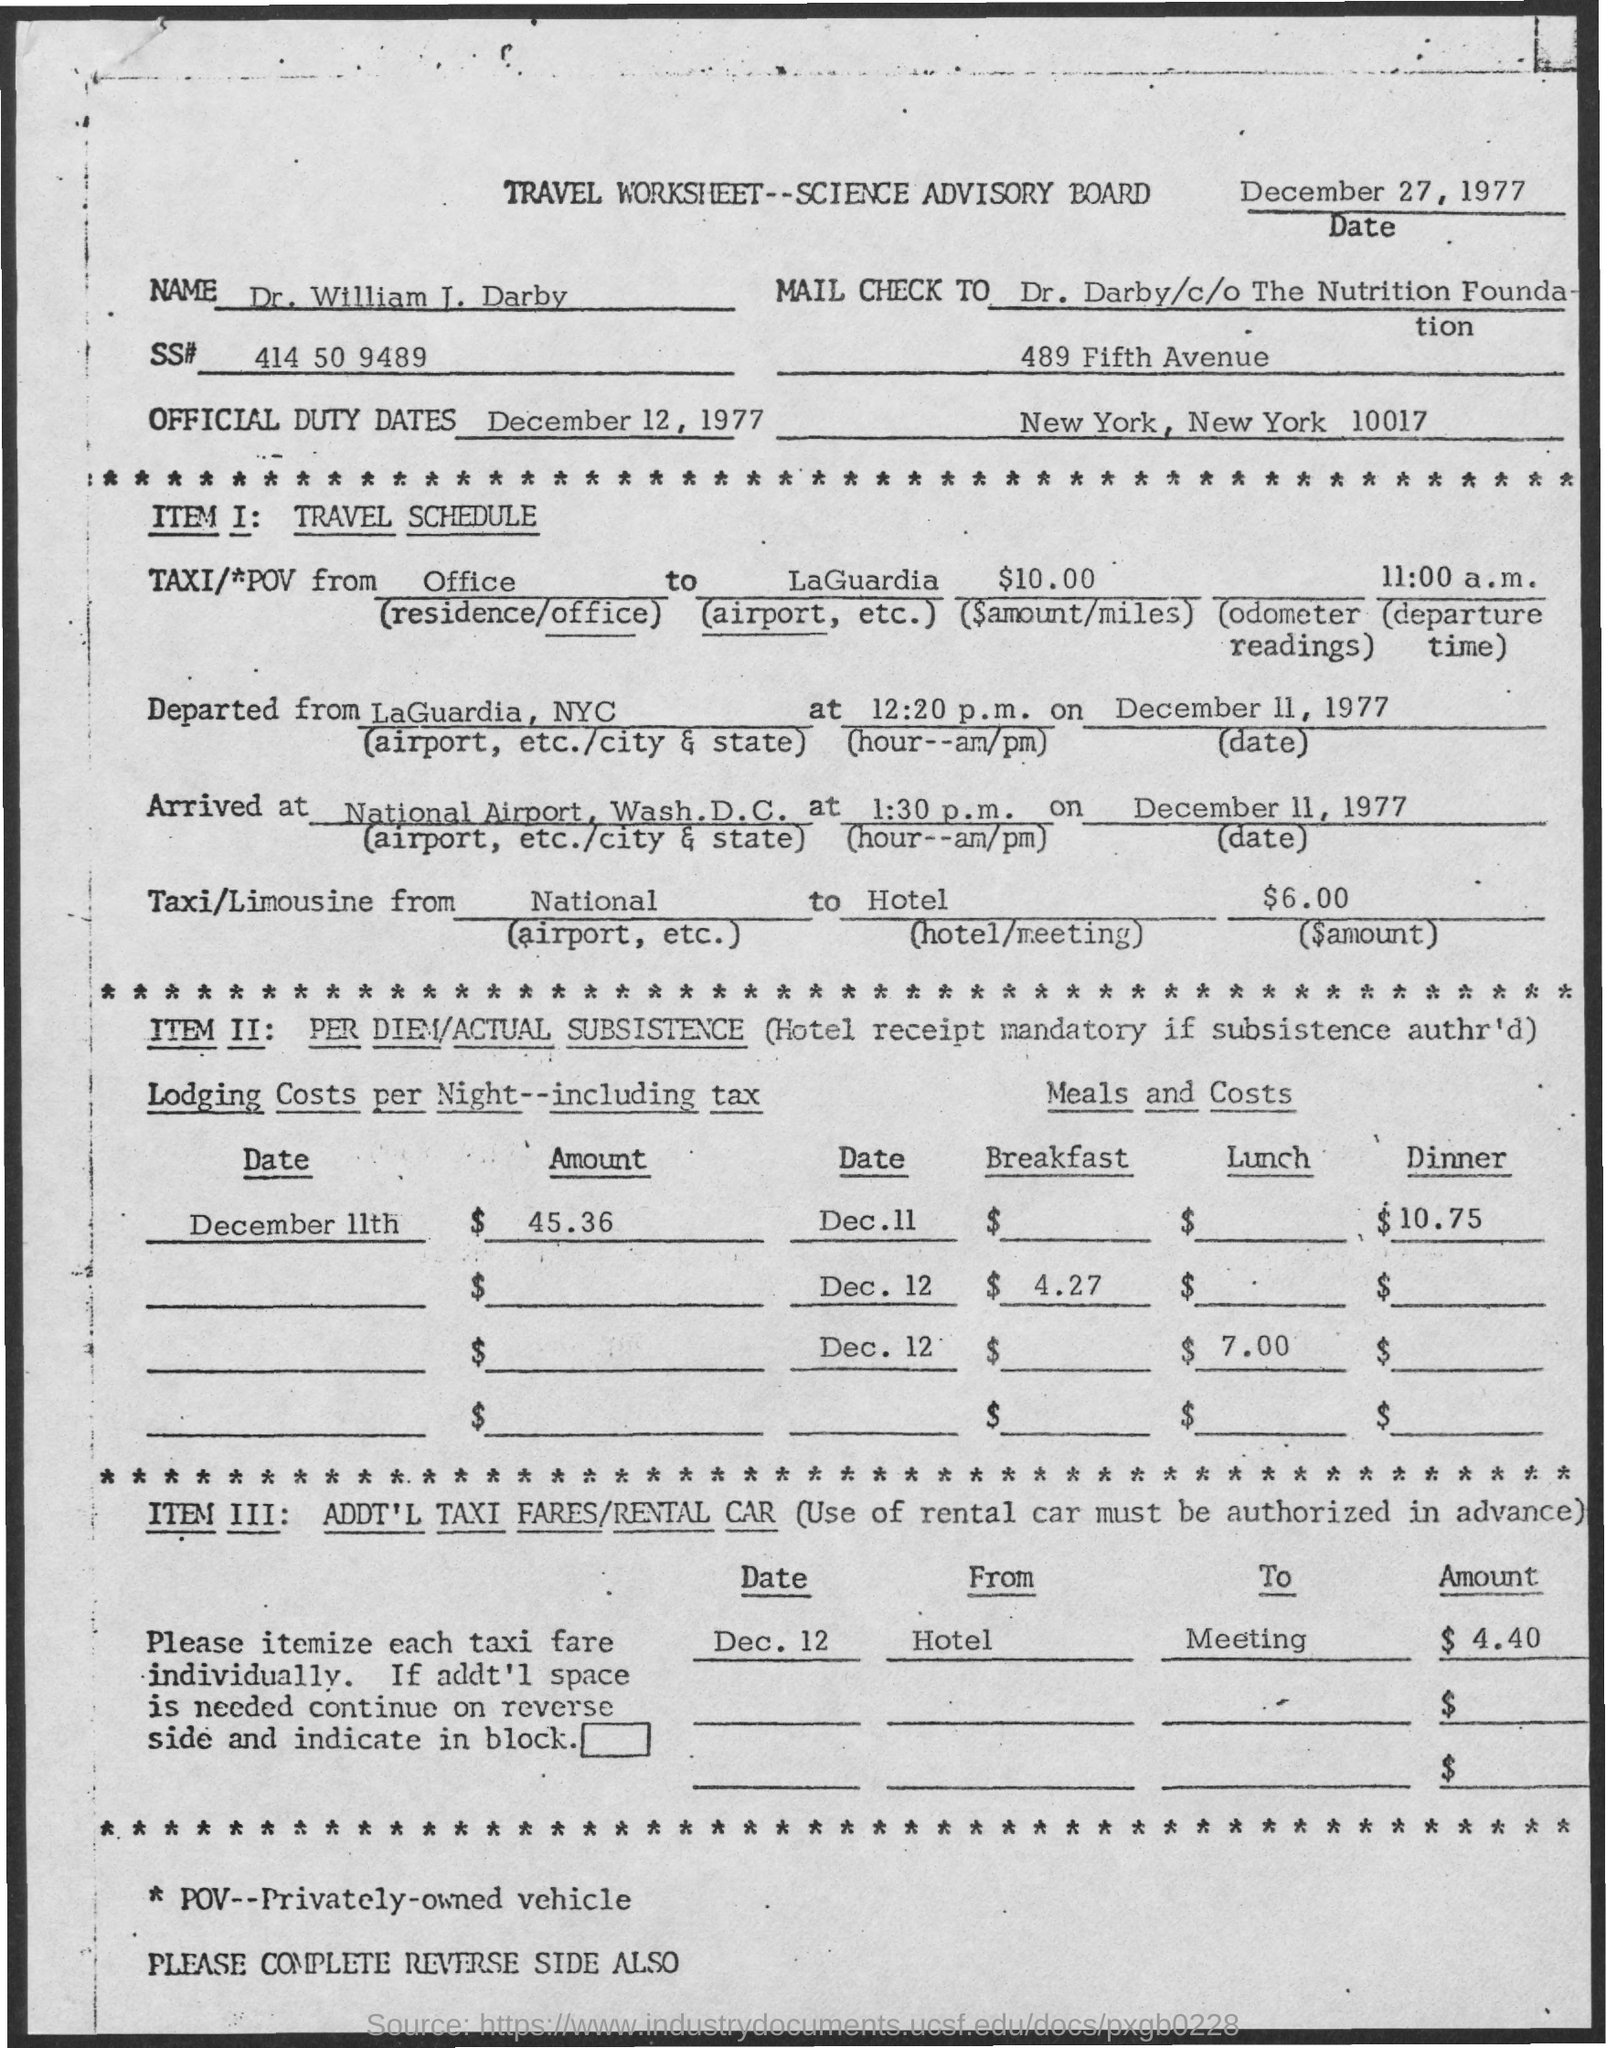What is the full form of POV?
Offer a terse response. Privately-Owned Vehicle. What is the SS# Number?
Keep it short and to the point. 414 50 9489. 